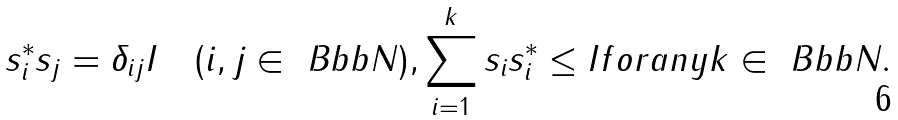Convert formula to latex. <formula><loc_0><loc_0><loc_500><loc_500>s _ { i } ^ { * } s _ { j } = \delta _ { i j } I \quad ( i , j \in { \ B b b N } ) , \sum _ { i = 1 } ^ { k } s _ { i } s _ { i } ^ { * } \leq I f o r a n y k \in { \ B b b N } .</formula> 